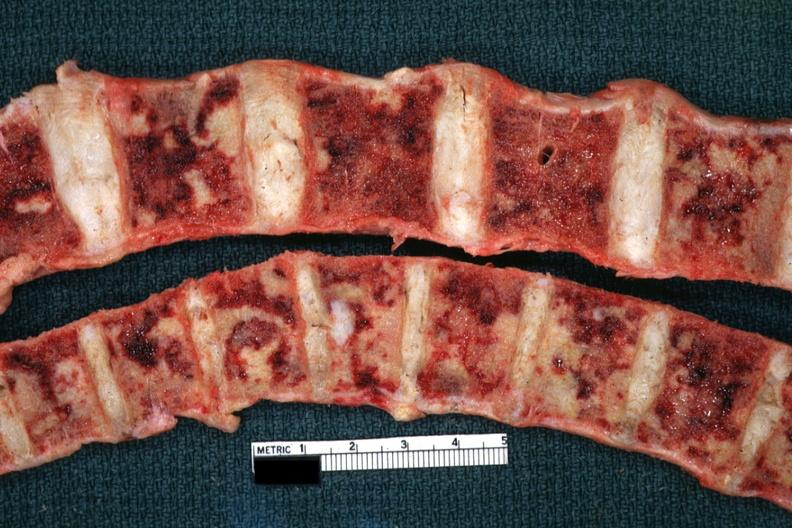what is present?
Answer the question using a single word or phrase. Joints 